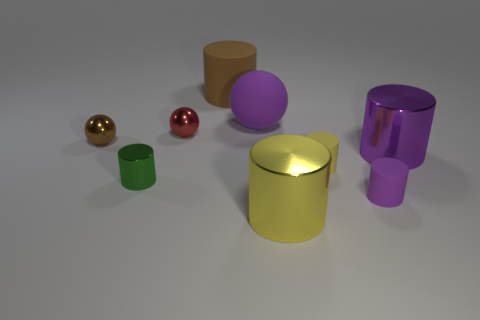Are the brown cylinder and the small green thing made of the same material?
Provide a succinct answer. No. Is there any other thing that is the same shape as the yellow metallic object?
Offer a terse response. Yes. What material is the big purple object behind the ball in front of the red object?
Your answer should be very brief. Rubber. What size is the red thing on the right side of the small green thing?
Your answer should be compact. Small. What color is the cylinder that is to the right of the yellow metallic cylinder and in front of the small green object?
Provide a short and direct response. Purple. Does the yellow cylinder that is in front of the green cylinder have the same size as the small yellow matte thing?
Keep it short and to the point. No. There is a large cylinder behind the big purple shiny cylinder; is there a metallic cylinder on the right side of it?
Offer a very short reply. Yes. What is the material of the green cylinder?
Provide a short and direct response. Metal. There is a red ball; are there any yellow cylinders to the left of it?
Your response must be concise. No. What size is the brown thing that is the same shape as the tiny purple matte object?
Keep it short and to the point. Large. 